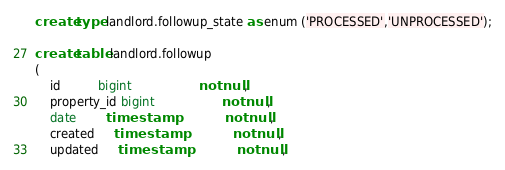<code> <loc_0><loc_0><loc_500><loc_500><_SQL_>create type landlord.followup_state as enum ('PROCESSED','UNPROCESSED');

create table landlord.followup
(
    id          bigint                  not null,
    property_id bigint                  not null,
    date        timestamp               not null,
    created     timestamp               not null,
    updated     timestamp               not null,</code> 